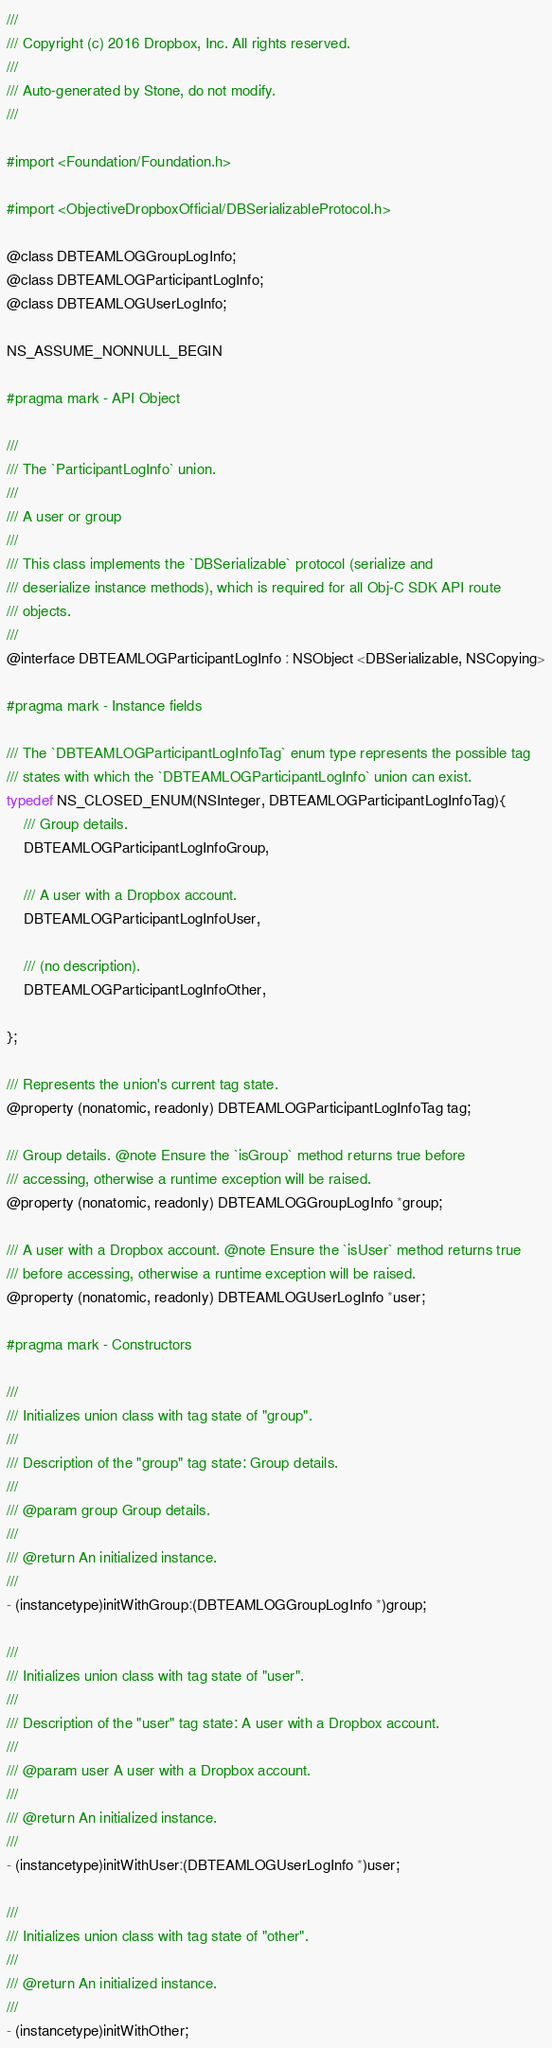Convert code to text. <code><loc_0><loc_0><loc_500><loc_500><_C_>///
/// Copyright (c) 2016 Dropbox, Inc. All rights reserved.
///
/// Auto-generated by Stone, do not modify.
///

#import <Foundation/Foundation.h>

#import <ObjectiveDropboxOfficial/DBSerializableProtocol.h>

@class DBTEAMLOGGroupLogInfo;
@class DBTEAMLOGParticipantLogInfo;
@class DBTEAMLOGUserLogInfo;

NS_ASSUME_NONNULL_BEGIN

#pragma mark - API Object

///
/// The `ParticipantLogInfo` union.
///
/// A user or group
///
/// This class implements the `DBSerializable` protocol (serialize and
/// deserialize instance methods), which is required for all Obj-C SDK API route
/// objects.
///
@interface DBTEAMLOGParticipantLogInfo : NSObject <DBSerializable, NSCopying>

#pragma mark - Instance fields

/// The `DBTEAMLOGParticipantLogInfoTag` enum type represents the possible tag
/// states with which the `DBTEAMLOGParticipantLogInfo` union can exist.
typedef NS_CLOSED_ENUM(NSInteger, DBTEAMLOGParticipantLogInfoTag){
    /// Group details.
    DBTEAMLOGParticipantLogInfoGroup,

    /// A user with a Dropbox account.
    DBTEAMLOGParticipantLogInfoUser,

    /// (no description).
    DBTEAMLOGParticipantLogInfoOther,

};

/// Represents the union's current tag state.
@property (nonatomic, readonly) DBTEAMLOGParticipantLogInfoTag tag;

/// Group details. @note Ensure the `isGroup` method returns true before
/// accessing, otherwise a runtime exception will be raised.
@property (nonatomic, readonly) DBTEAMLOGGroupLogInfo *group;

/// A user with a Dropbox account. @note Ensure the `isUser` method returns true
/// before accessing, otherwise a runtime exception will be raised.
@property (nonatomic, readonly) DBTEAMLOGUserLogInfo *user;

#pragma mark - Constructors

///
/// Initializes union class with tag state of "group".
///
/// Description of the "group" tag state: Group details.
///
/// @param group Group details.
///
/// @return An initialized instance.
///
- (instancetype)initWithGroup:(DBTEAMLOGGroupLogInfo *)group;

///
/// Initializes union class with tag state of "user".
///
/// Description of the "user" tag state: A user with a Dropbox account.
///
/// @param user A user with a Dropbox account.
///
/// @return An initialized instance.
///
- (instancetype)initWithUser:(DBTEAMLOGUserLogInfo *)user;

///
/// Initializes union class with tag state of "other".
///
/// @return An initialized instance.
///
- (instancetype)initWithOther;
</code> 